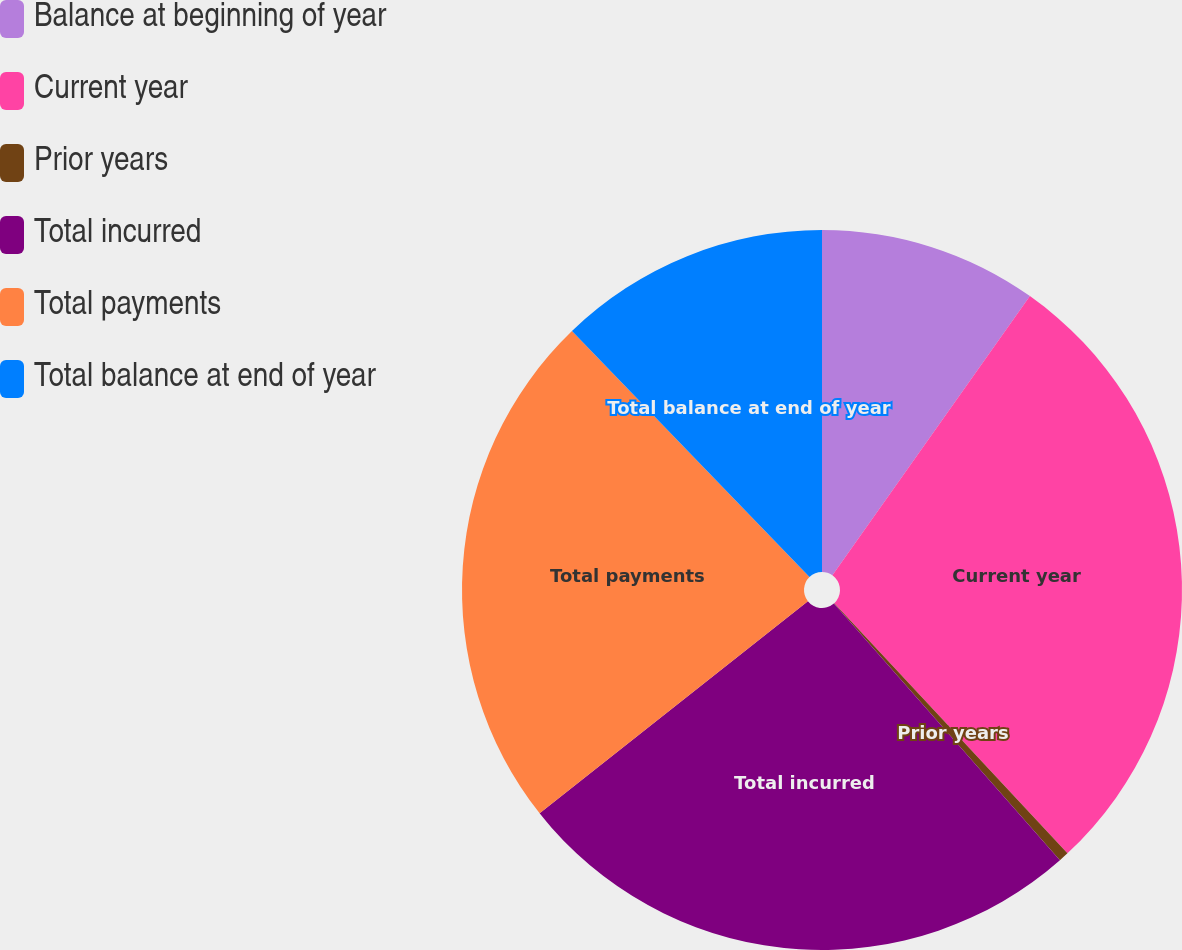Convert chart. <chart><loc_0><loc_0><loc_500><loc_500><pie_chart><fcel>Balance at beginning of year<fcel>Current year<fcel>Prior years<fcel>Total incurred<fcel>Total payments<fcel>Total balance at end of year<nl><fcel>9.8%<fcel>28.26%<fcel>0.45%<fcel>25.84%<fcel>23.43%<fcel>12.22%<nl></chart> 